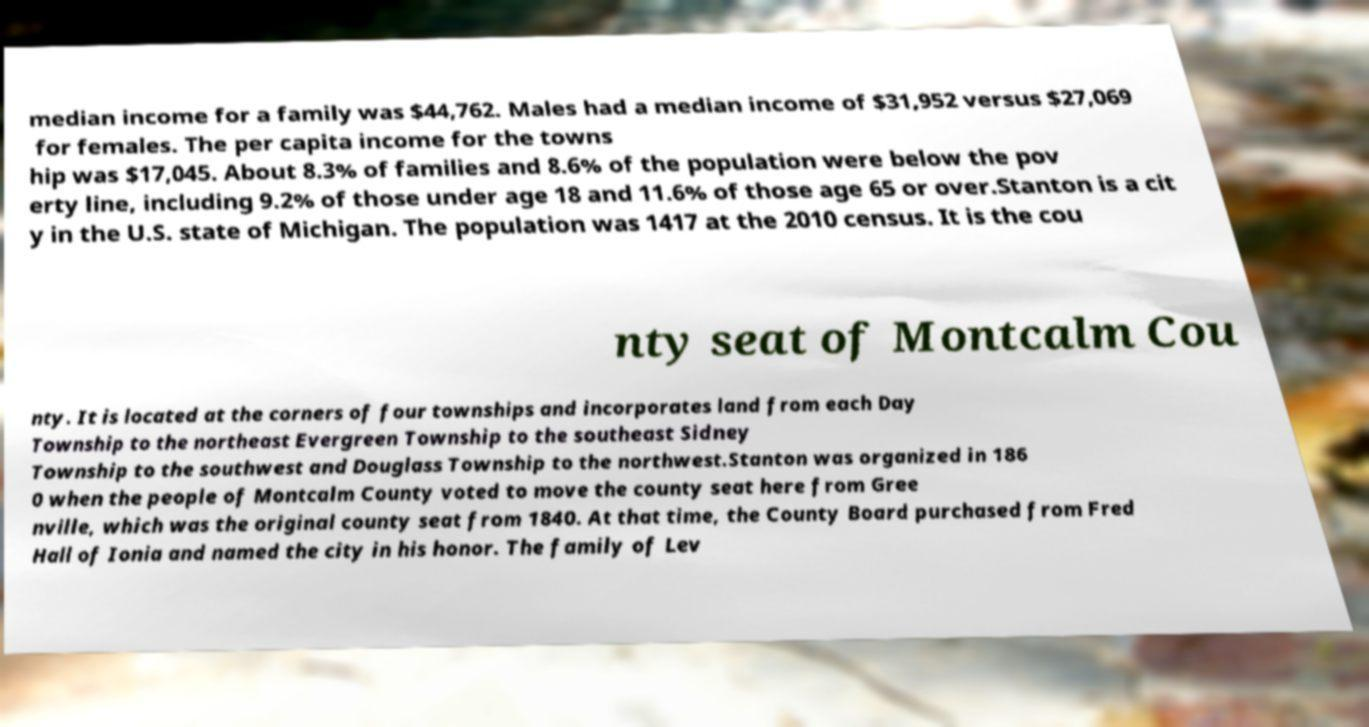I need the written content from this picture converted into text. Can you do that? median income for a family was $44,762. Males had a median income of $31,952 versus $27,069 for females. The per capita income for the towns hip was $17,045. About 8.3% of families and 8.6% of the population were below the pov erty line, including 9.2% of those under age 18 and 11.6% of those age 65 or over.Stanton is a cit y in the U.S. state of Michigan. The population was 1417 at the 2010 census. It is the cou nty seat of Montcalm Cou nty. It is located at the corners of four townships and incorporates land from each Day Township to the northeast Evergreen Township to the southeast Sidney Township to the southwest and Douglass Township to the northwest.Stanton was organized in 186 0 when the people of Montcalm County voted to move the county seat here from Gree nville, which was the original county seat from 1840. At that time, the County Board purchased from Fred Hall of Ionia and named the city in his honor. The family of Lev 